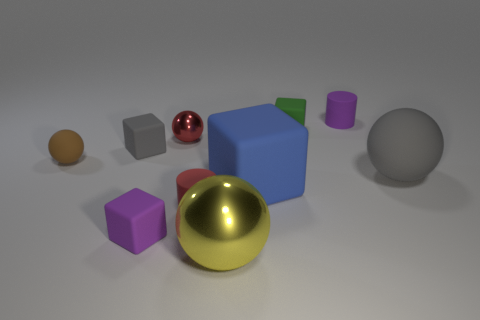Can you explain the lighting in the scene? Where might the light source be located? The shadows cast by the objects suggest that there is a single light source located above the scene, slightly to the left. This light source diffusely illuminates the scene, creating soft-edged shadows and giving the objects a gentle glow. 